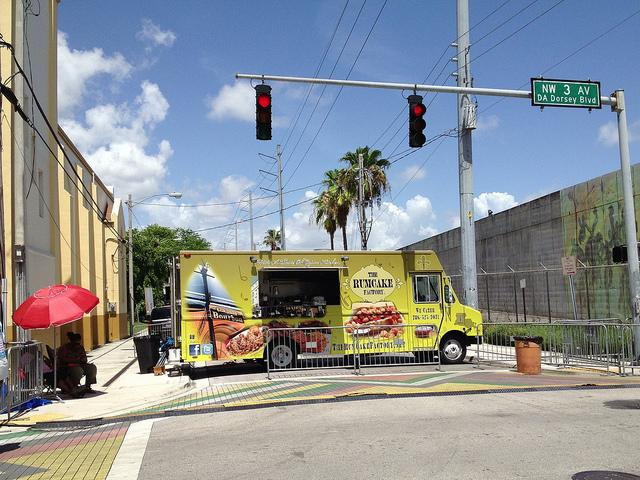What is the yellow truck doing?

Choices:
A) selling food
B) extinguishing fire
C) repairing ground
D) delivering mail selling food 